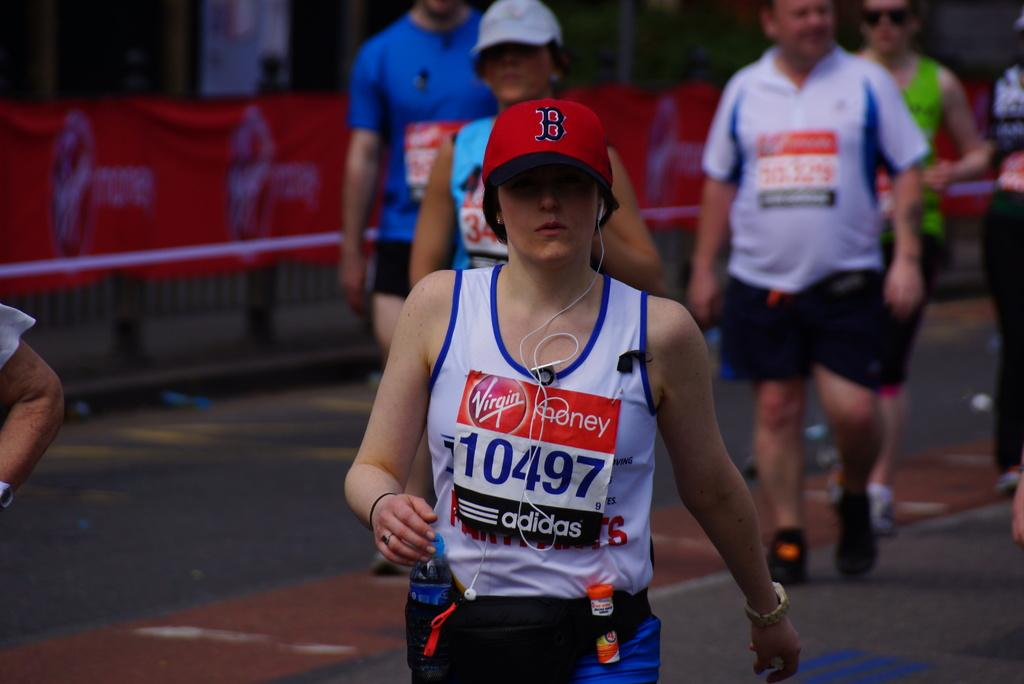Provide a one-sentence caption for the provided image. Adidas and Virgin Money are sponsoring a runner wearing a Boston hat. 